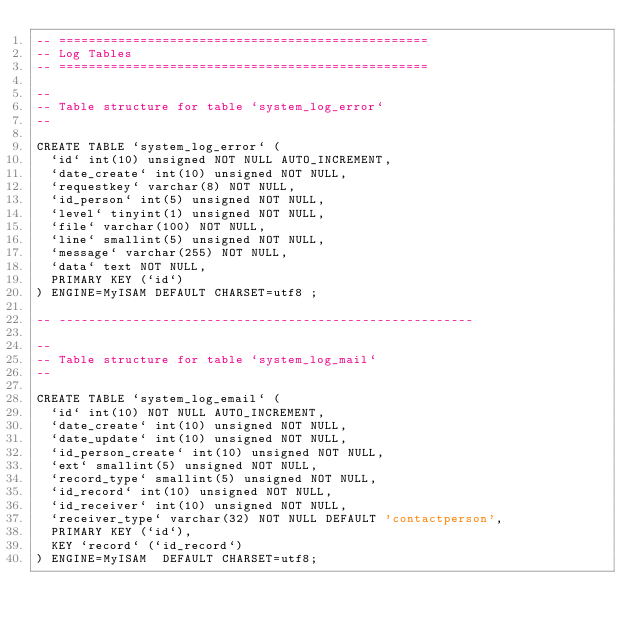<code> <loc_0><loc_0><loc_500><loc_500><_SQL_>-- ==================================================
-- Log Tables
-- ==================================================

--
-- Table structure for table `system_log_error`
--

CREATE TABLE `system_log_error` (
	`id` int(10) unsigned NOT NULL AUTO_INCREMENT,
	`date_create` int(10) unsigned NOT NULL,
	`requestkey` varchar(8) NOT NULL,
	`id_person` int(5) unsigned NOT NULL,
	`level` tinyint(1) unsigned NOT NULL,
	`file` varchar(100) NOT NULL,
	`line` smallint(5) unsigned NOT NULL,
	`message` varchar(255) NOT NULL,
	`data` text NOT NULL,
	PRIMARY KEY (`id`)
) ENGINE=MyISAM DEFAULT CHARSET=utf8 ;

-- --------------------------------------------------------

--
-- Table structure for table `system_log_mail`
--

CREATE TABLE `system_log_email` (
	`id` int(10) NOT NULL AUTO_INCREMENT,
	`date_create` int(10) unsigned NOT NULL,
	`date_update` int(10) unsigned NOT NULL,
	`id_person_create` int(10) unsigned NOT NULL,
	`ext` smallint(5) unsigned NOT NULL,
	`record_type` smallint(5) unsigned NOT NULL,
	`id_record` int(10) unsigned NOT NULL,
	`id_receiver` int(10) unsigned NOT NULL,
	`receiver_type` varchar(32) NOT NULL DEFAULT 'contactperson',
	PRIMARY KEY (`id`),
	KEY `record` (`id_record`)
) ENGINE=MyISAM  DEFAULT CHARSET=utf8;
</code> 